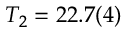<formula> <loc_0><loc_0><loc_500><loc_500>T _ { 2 } = 2 2 . 7 ( 4 )</formula> 